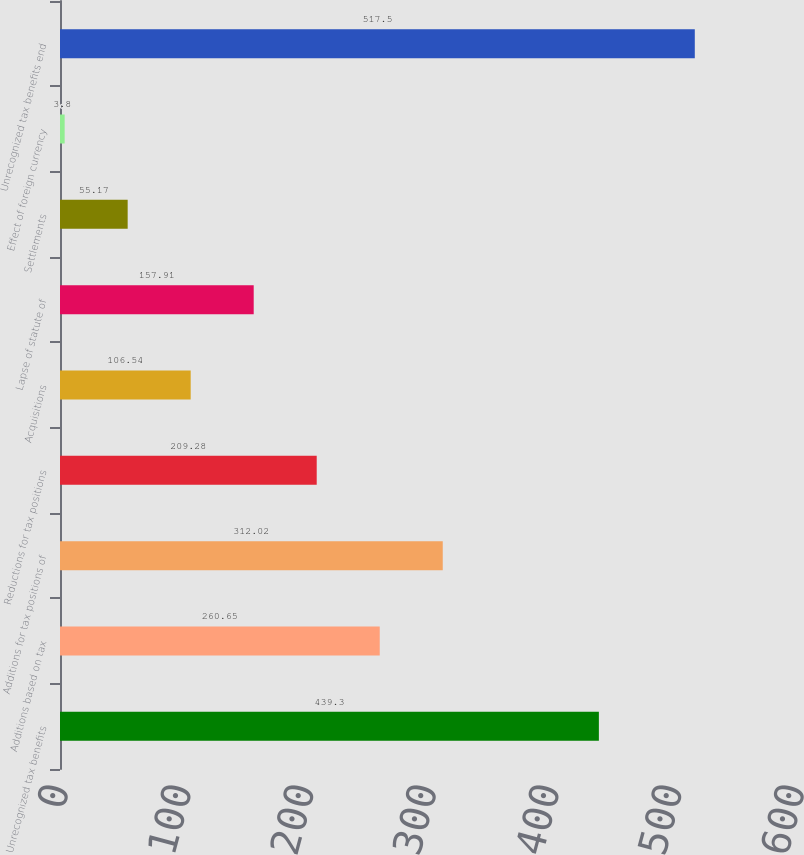<chart> <loc_0><loc_0><loc_500><loc_500><bar_chart><fcel>Unrecognized tax benefits<fcel>Additions based on tax<fcel>Additions for tax positions of<fcel>Reductions for tax positions<fcel>Acquisitions<fcel>Lapse of statute of<fcel>Settlements<fcel>Effect of foreign currency<fcel>Unrecognized tax benefits end<nl><fcel>439.3<fcel>260.65<fcel>312.02<fcel>209.28<fcel>106.54<fcel>157.91<fcel>55.17<fcel>3.8<fcel>517.5<nl></chart> 